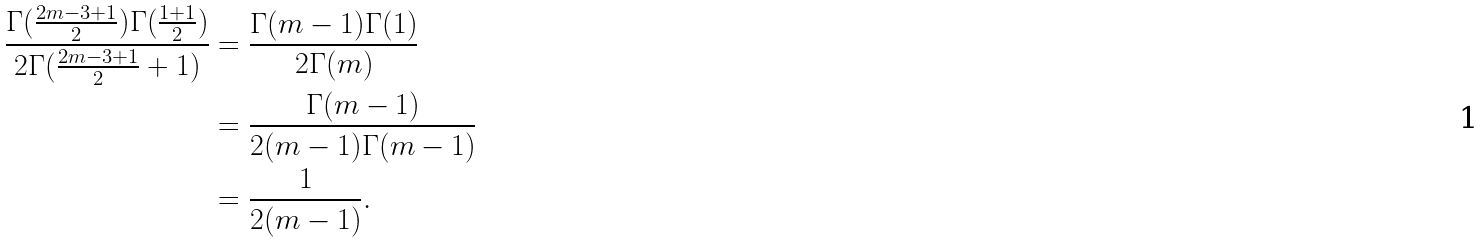Convert formula to latex. <formula><loc_0><loc_0><loc_500><loc_500>\frac { \Gamma ( \frac { 2 m - 3 + 1 } { 2 } ) \Gamma ( \frac { 1 + 1 } { 2 } ) } { 2 \Gamma ( \frac { 2 m - 3 + 1 } { 2 } + 1 ) } & = \frac { \Gamma ( m - 1 ) \Gamma ( 1 ) } { 2 \Gamma ( m ) } \\ & = \frac { \Gamma ( m - 1 ) } { 2 ( m - 1 ) \Gamma ( m - 1 ) } \\ & = \frac { 1 } { 2 ( m - 1 ) } .</formula> 